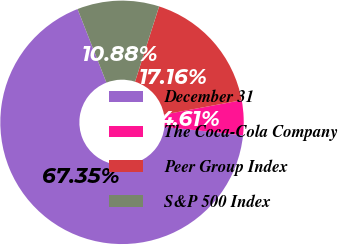<chart> <loc_0><loc_0><loc_500><loc_500><pie_chart><fcel>December 31<fcel>The Coca-Cola Company<fcel>Peer Group Index<fcel>S&P 500 Index<nl><fcel>67.35%<fcel>4.61%<fcel>17.16%<fcel>10.88%<nl></chart> 